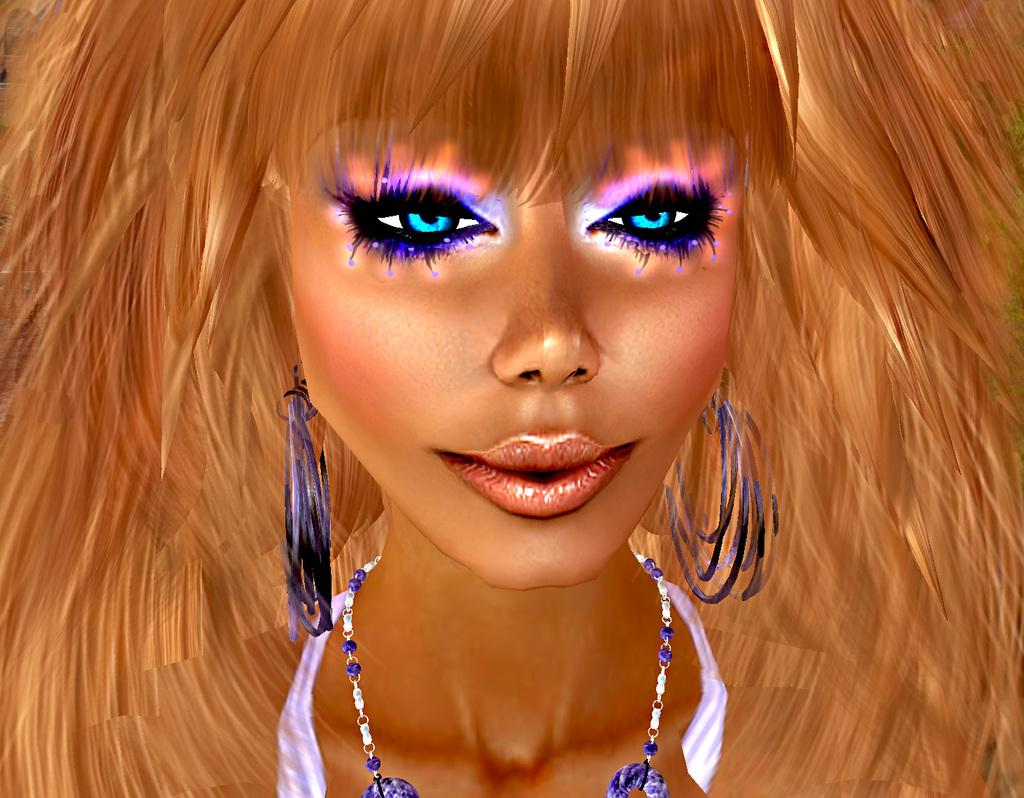What type of picture is in the image? The image contains an animated picture of a woman. What accessory is the woman wearing in the image? The woman in the image is wearing a chain around her neck. What colors can be seen in the image? The colors violet, blue, brown, and black are present in the image. Where is the faucet located in the image? There is no faucet present in the image; it features an animated picture of a woman. What type of coil is wrapped around the woman's arm in the image? There is no coil present in the image; the woman is wearing a chain around her neck. 